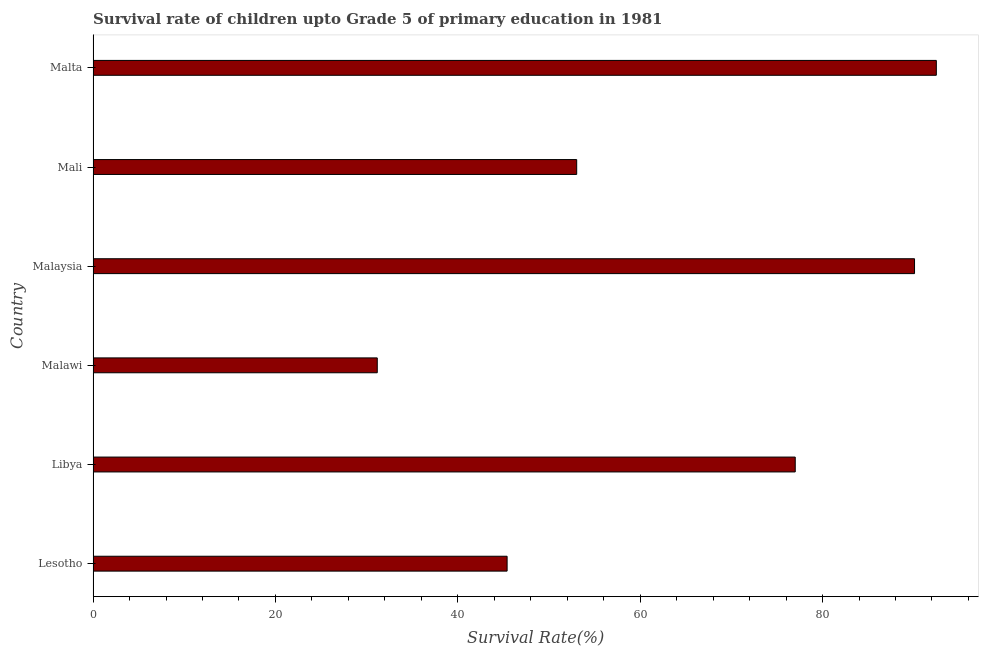Does the graph contain any zero values?
Provide a short and direct response. No. Does the graph contain grids?
Provide a short and direct response. No. What is the title of the graph?
Provide a short and direct response. Survival rate of children upto Grade 5 of primary education in 1981 . What is the label or title of the X-axis?
Make the answer very short. Survival Rate(%). What is the survival rate in Lesotho?
Provide a short and direct response. 45.4. Across all countries, what is the maximum survival rate?
Provide a succinct answer. 92.48. Across all countries, what is the minimum survival rate?
Provide a succinct answer. 31.16. In which country was the survival rate maximum?
Provide a succinct answer. Malta. In which country was the survival rate minimum?
Provide a short and direct response. Malawi. What is the sum of the survival rate?
Make the answer very short. 389.17. What is the difference between the survival rate in Libya and Malta?
Your response must be concise. -15.47. What is the average survival rate per country?
Provide a short and direct response. 64.86. What is the median survival rate?
Keep it short and to the point. 65.02. In how many countries, is the survival rate greater than 16 %?
Give a very brief answer. 6. What is the ratio of the survival rate in Libya to that in Malta?
Make the answer very short. 0.83. Is the survival rate in Malawi less than that in Mali?
Your answer should be compact. Yes. Is the difference between the survival rate in Malaysia and Malta greater than the difference between any two countries?
Make the answer very short. No. What is the difference between the highest and the second highest survival rate?
Ensure brevity in your answer.  2.39. Is the sum of the survival rate in Malaysia and Malta greater than the maximum survival rate across all countries?
Keep it short and to the point. Yes. What is the difference between the highest and the lowest survival rate?
Offer a terse response. 61.31. In how many countries, is the survival rate greater than the average survival rate taken over all countries?
Provide a succinct answer. 3. What is the difference between two consecutive major ticks on the X-axis?
Offer a terse response. 20. What is the Survival Rate(%) in Lesotho?
Provide a short and direct response. 45.4. What is the Survival Rate(%) in Libya?
Your answer should be very brief. 77. What is the Survival Rate(%) in Malawi?
Offer a terse response. 31.16. What is the Survival Rate(%) of Malaysia?
Give a very brief answer. 90.09. What is the Survival Rate(%) of Mali?
Offer a terse response. 53.04. What is the Survival Rate(%) in Malta?
Make the answer very short. 92.48. What is the difference between the Survival Rate(%) in Lesotho and Libya?
Make the answer very short. -31.6. What is the difference between the Survival Rate(%) in Lesotho and Malawi?
Your response must be concise. 14.24. What is the difference between the Survival Rate(%) in Lesotho and Malaysia?
Offer a very short reply. -44.68. What is the difference between the Survival Rate(%) in Lesotho and Mali?
Your answer should be very brief. -7.63. What is the difference between the Survival Rate(%) in Lesotho and Malta?
Provide a succinct answer. -47.07. What is the difference between the Survival Rate(%) in Libya and Malawi?
Offer a terse response. 45.84. What is the difference between the Survival Rate(%) in Libya and Malaysia?
Give a very brief answer. -13.08. What is the difference between the Survival Rate(%) in Libya and Mali?
Offer a terse response. 23.97. What is the difference between the Survival Rate(%) in Libya and Malta?
Provide a succinct answer. -15.47. What is the difference between the Survival Rate(%) in Malawi and Malaysia?
Offer a very short reply. -58.92. What is the difference between the Survival Rate(%) in Malawi and Mali?
Your response must be concise. -21.87. What is the difference between the Survival Rate(%) in Malawi and Malta?
Give a very brief answer. -61.31. What is the difference between the Survival Rate(%) in Malaysia and Mali?
Provide a short and direct response. 37.05. What is the difference between the Survival Rate(%) in Malaysia and Malta?
Your answer should be compact. -2.39. What is the difference between the Survival Rate(%) in Mali and Malta?
Keep it short and to the point. -39.44. What is the ratio of the Survival Rate(%) in Lesotho to that in Libya?
Give a very brief answer. 0.59. What is the ratio of the Survival Rate(%) in Lesotho to that in Malawi?
Ensure brevity in your answer.  1.46. What is the ratio of the Survival Rate(%) in Lesotho to that in Malaysia?
Make the answer very short. 0.5. What is the ratio of the Survival Rate(%) in Lesotho to that in Mali?
Your response must be concise. 0.86. What is the ratio of the Survival Rate(%) in Lesotho to that in Malta?
Your response must be concise. 0.49. What is the ratio of the Survival Rate(%) in Libya to that in Malawi?
Your answer should be very brief. 2.47. What is the ratio of the Survival Rate(%) in Libya to that in Malaysia?
Provide a succinct answer. 0.85. What is the ratio of the Survival Rate(%) in Libya to that in Mali?
Offer a terse response. 1.45. What is the ratio of the Survival Rate(%) in Libya to that in Malta?
Your response must be concise. 0.83. What is the ratio of the Survival Rate(%) in Malawi to that in Malaysia?
Make the answer very short. 0.35. What is the ratio of the Survival Rate(%) in Malawi to that in Mali?
Make the answer very short. 0.59. What is the ratio of the Survival Rate(%) in Malawi to that in Malta?
Provide a short and direct response. 0.34. What is the ratio of the Survival Rate(%) in Malaysia to that in Mali?
Keep it short and to the point. 1.7. What is the ratio of the Survival Rate(%) in Mali to that in Malta?
Make the answer very short. 0.57. 